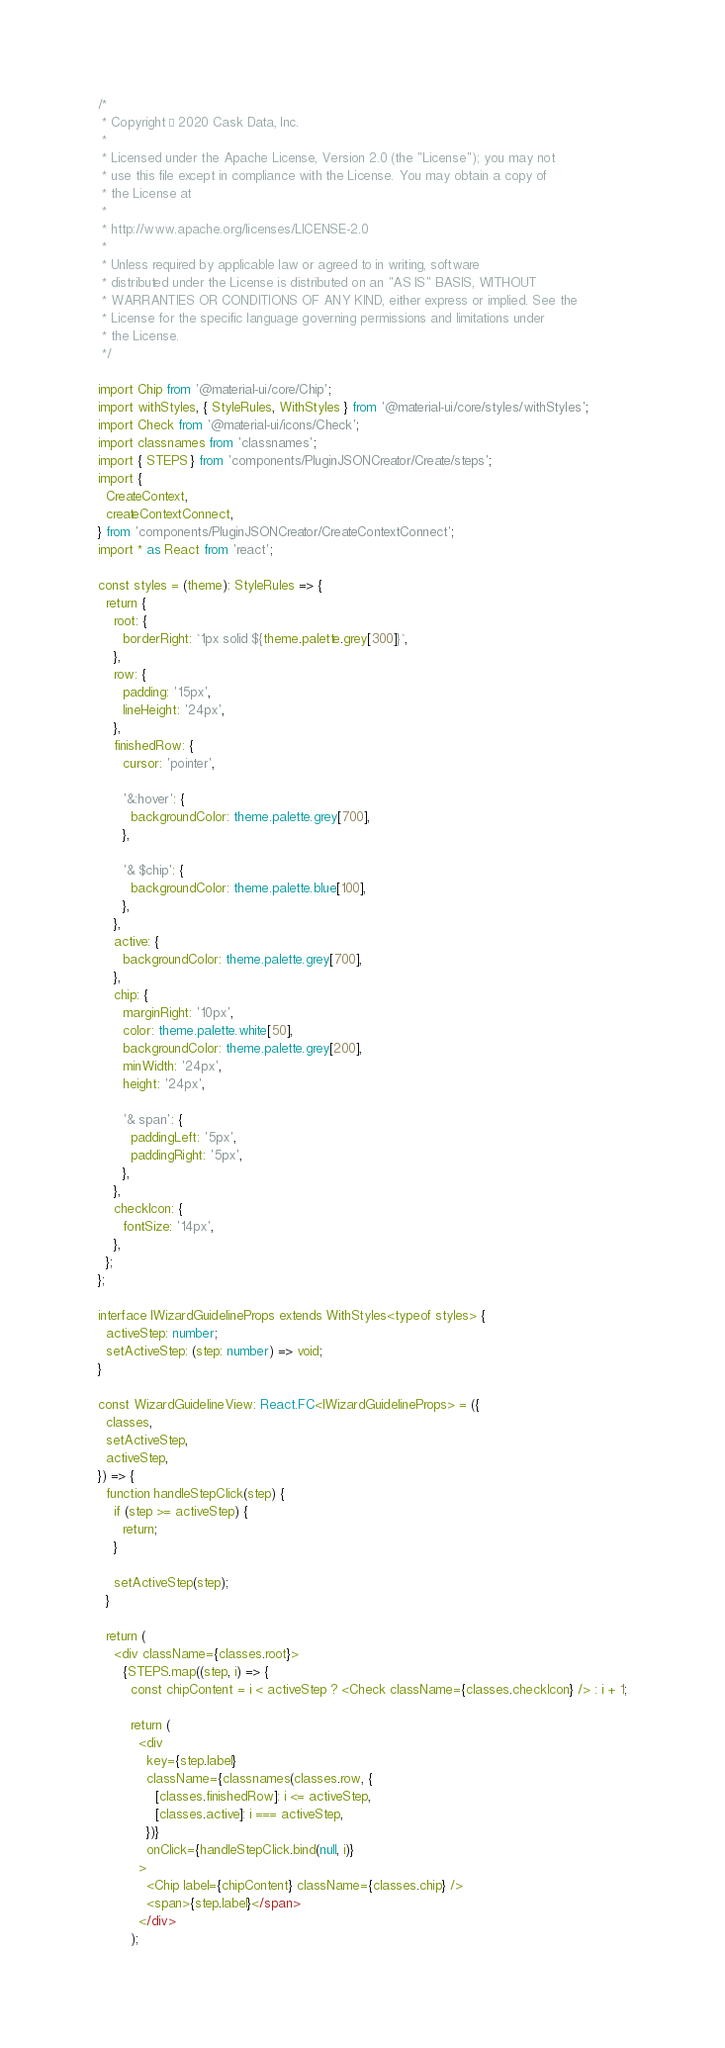<code> <loc_0><loc_0><loc_500><loc_500><_TypeScript_>/*
 * Copyright © 2020 Cask Data, Inc.
 *
 * Licensed under the Apache License, Version 2.0 (the "License"); you may not
 * use this file except in compliance with the License. You may obtain a copy of
 * the License at
 *
 * http://www.apache.org/licenses/LICENSE-2.0
 *
 * Unless required by applicable law or agreed to in writing, software
 * distributed under the License is distributed on an "AS IS" BASIS, WITHOUT
 * WARRANTIES OR CONDITIONS OF ANY KIND, either express or implied. See the
 * License for the specific language governing permissions and limitations under
 * the License.
 */

import Chip from '@material-ui/core/Chip';
import withStyles, { StyleRules, WithStyles } from '@material-ui/core/styles/withStyles';
import Check from '@material-ui/icons/Check';
import classnames from 'classnames';
import { STEPS } from 'components/PluginJSONCreator/Create/steps';
import {
  CreateContext,
  createContextConnect,
} from 'components/PluginJSONCreator/CreateContextConnect';
import * as React from 'react';

const styles = (theme): StyleRules => {
  return {
    root: {
      borderRight: `1px solid ${theme.palette.grey[300]}`,
    },
    row: {
      padding: '15px',
      lineHeight: '24px',
    },
    finishedRow: {
      cursor: 'pointer',

      '&:hover': {
        backgroundColor: theme.palette.grey[700],
      },

      '& $chip': {
        backgroundColor: theme.palette.blue[100],
      },
    },
    active: {
      backgroundColor: theme.palette.grey[700],
    },
    chip: {
      marginRight: '10px',
      color: theme.palette.white[50],
      backgroundColor: theme.palette.grey[200],
      minWidth: '24px',
      height: '24px',

      '& span': {
        paddingLeft: '5px',
        paddingRight: '5px',
      },
    },
    checkIcon: {
      fontSize: '14px',
    },
  };
};

interface IWizardGuidelineProps extends WithStyles<typeof styles> {
  activeStep: number;
  setActiveStep: (step: number) => void;
}

const WizardGuidelineView: React.FC<IWizardGuidelineProps> = ({
  classes,
  setActiveStep,
  activeStep,
}) => {
  function handleStepClick(step) {
    if (step >= activeStep) {
      return;
    }

    setActiveStep(step);
  }

  return (
    <div className={classes.root}>
      {STEPS.map((step, i) => {
        const chipContent = i < activeStep ? <Check className={classes.checkIcon} /> : i + 1;

        return (
          <div
            key={step.label}
            className={classnames(classes.row, {
              [classes.finishedRow]: i <= activeStep,
              [classes.active]: i === activeStep,
            })}
            onClick={handleStepClick.bind(null, i)}
          >
            <Chip label={chipContent} className={classes.chip} />
            <span>{step.label}</span>
          </div>
        );</code> 